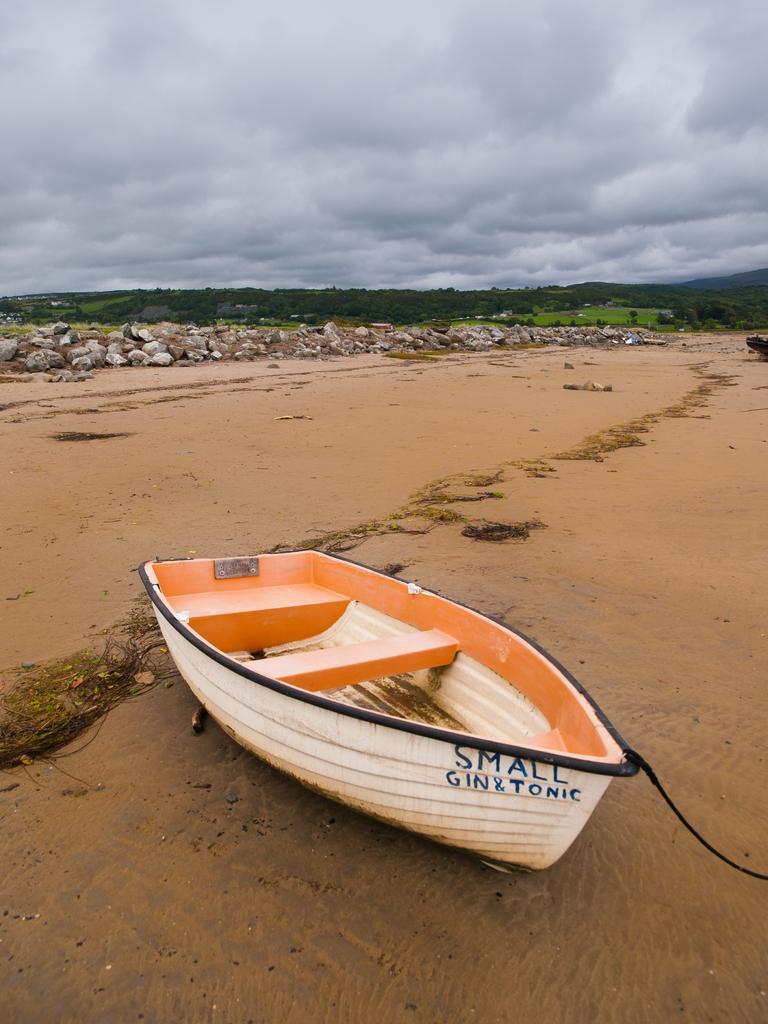Describe this image in one or two sentences. In this image in front there is a boat. At the bottom of the image there is a sand. In the center of the image there are rocks. In the background of the image there are trees and sky. 